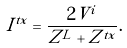<formula> <loc_0><loc_0><loc_500><loc_500>I ^ { t x } = \frac { 2 V ^ { i } } { Z ^ { L } + Z ^ { t x } } .</formula> 